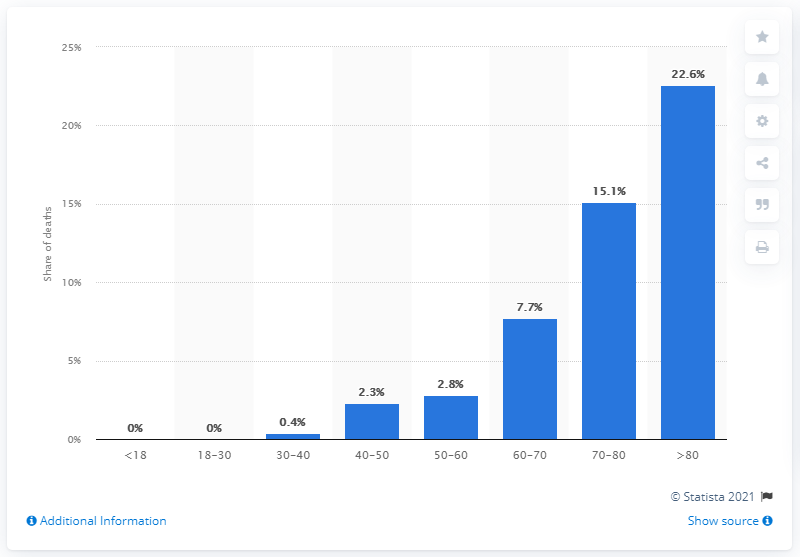Mention a couple of crucial points in this snapshot. The highest rate of death due to COVID-19 in Poland is among individuals aged 70 to 80 years old. 